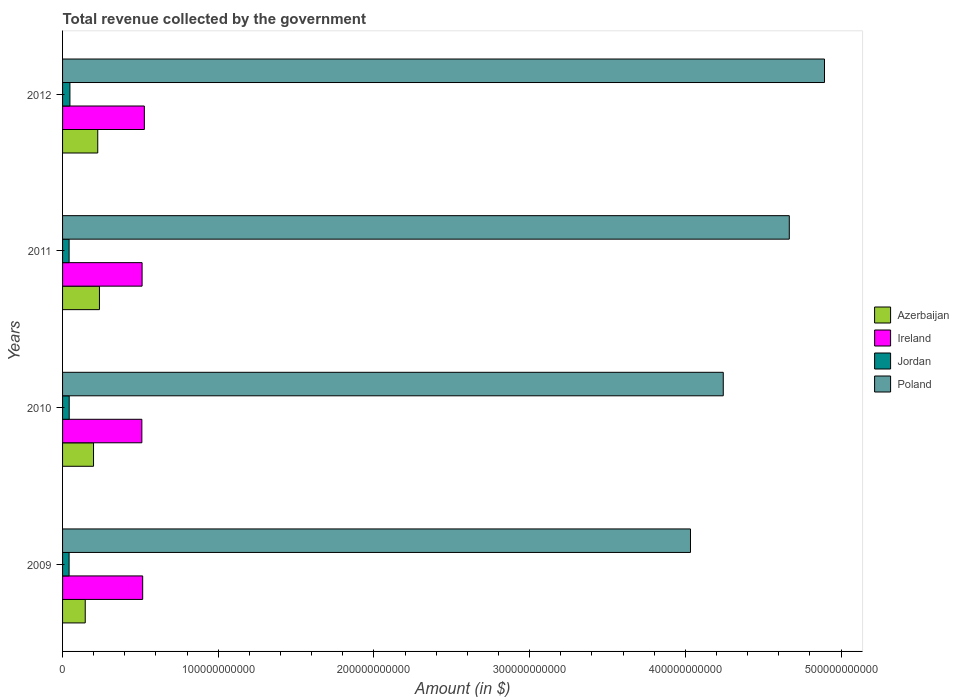How many different coloured bars are there?
Your answer should be compact. 4. How many groups of bars are there?
Give a very brief answer. 4. Are the number of bars per tick equal to the number of legend labels?
Offer a terse response. Yes. How many bars are there on the 3rd tick from the top?
Keep it short and to the point. 4. What is the label of the 1st group of bars from the top?
Offer a very short reply. 2012. What is the total revenue collected by the government in Azerbaijan in 2011?
Make the answer very short. 2.37e+1. Across all years, what is the maximum total revenue collected by the government in Azerbaijan?
Ensure brevity in your answer.  2.37e+1. Across all years, what is the minimum total revenue collected by the government in Poland?
Offer a very short reply. 4.03e+11. In which year was the total revenue collected by the government in Azerbaijan maximum?
Ensure brevity in your answer.  2011. What is the total total revenue collected by the government in Ireland in the graph?
Make the answer very short. 2.06e+11. What is the difference between the total revenue collected by the government in Ireland in 2009 and that in 2011?
Your response must be concise. 3.85e+08. What is the difference between the total revenue collected by the government in Ireland in 2009 and the total revenue collected by the government in Poland in 2012?
Ensure brevity in your answer.  -4.38e+11. What is the average total revenue collected by the government in Jordan per year?
Offer a very short reply. 4.34e+09. In the year 2011, what is the difference between the total revenue collected by the government in Jordan and total revenue collected by the government in Azerbaijan?
Offer a very short reply. -1.95e+1. In how many years, is the total revenue collected by the government in Jordan greater than 460000000000 $?
Ensure brevity in your answer.  0. What is the ratio of the total revenue collected by the government in Ireland in 2009 to that in 2011?
Provide a short and direct response. 1.01. What is the difference between the highest and the second highest total revenue collected by the government in Azerbaijan?
Provide a short and direct response. 1.09e+09. What is the difference between the highest and the lowest total revenue collected by the government in Azerbaijan?
Make the answer very short. 9.13e+09. Is the sum of the total revenue collected by the government in Azerbaijan in 2010 and 2011 greater than the maximum total revenue collected by the government in Jordan across all years?
Ensure brevity in your answer.  Yes. What does the 3rd bar from the top in 2012 represents?
Provide a short and direct response. Ireland. What does the 2nd bar from the bottom in 2010 represents?
Your answer should be compact. Ireland. Are all the bars in the graph horizontal?
Offer a very short reply. Yes. How many years are there in the graph?
Ensure brevity in your answer.  4. What is the difference between two consecutive major ticks on the X-axis?
Ensure brevity in your answer.  1.00e+11. Does the graph contain any zero values?
Give a very brief answer. No. Where does the legend appear in the graph?
Offer a terse response. Center right. What is the title of the graph?
Your answer should be compact. Total revenue collected by the government. What is the label or title of the X-axis?
Make the answer very short. Amount (in $). What is the Amount (in $) in Azerbaijan in 2009?
Offer a very short reply. 1.46e+1. What is the Amount (in $) in Ireland in 2009?
Your answer should be very brief. 5.15e+1. What is the Amount (in $) of Jordan in 2009?
Your answer should be very brief. 4.19e+09. What is the Amount (in $) in Poland in 2009?
Offer a very short reply. 4.03e+11. What is the Amount (in $) of Azerbaijan in 2010?
Offer a very short reply. 1.99e+1. What is the Amount (in $) of Ireland in 2010?
Keep it short and to the point. 5.09e+1. What is the Amount (in $) of Jordan in 2010?
Your answer should be compact. 4.26e+09. What is the Amount (in $) in Poland in 2010?
Your response must be concise. 4.24e+11. What is the Amount (in $) in Azerbaijan in 2011?
Keep it short and to the point. 2.37e+1. What is the Amount (in $) in Ireland in 2011?
Your response must be concise. 5.11e+1. What is the Amount (in $) of Jordan in 2011?
Your response must be concise. 4.20e+09. What is the Amount (in $) of Poland in 2011?
Make the answer very short. 4.67e+11. What is the Amount (in $) in Azerbaijan in 2012?
Your answer should be very brief. 2.26e+1. What is the Amount (in $) of Ireland in 2012?
Make the answer very short. 5.25e+1. What is the Amount (in $) of Jordan in 2012?
Offer a very short reply. 4.73e+09. What is the Amount (in $) of Poland in 2012?
Ensure brevity in your answer.  4.89e+11. Across all years, what is the maximum Amount (in $) in Azerbaijan?
Give a very brief answer. 2.37e+1. Across all years, what is the maximum Amount (in $) of Ireland?
Make the answer very short. 5.25e+1. Across all years, what is the maximum Amount (in $) in Jordan?
Provide a short and direct response. 4.73e+09. Across all years, what is the maximum Amount (in $) in Poland?
Ensure brevity in your answer.  4.89e+11. Across all years, what is the minimum Amount (in $) in Azerbaijan?
Ensure brevity in your answer.  1.46e+1. Across all years, what is the minimum Amount (in $) of Ireland?
Provide a succinct answer. 5.09e+1. Across all years, what is the minimum Amount (in $) in Jordan?
Your answer should be very brief. 4.19e+09. Across all years, what is the minimum Amount (in $) in Poland?
Give a very brief answer. 4.03e+11. What is the total Amount (in $) of Azerbaijan in the graph?
Your answer should be compact. 8.07e+1. What is the total Amount (in $) in Ireland in the graph?
Give a very brief answer. 2.06e+11. What is the total Amount (in $) of Jordan in the graph?
Make the answer very short. 1.74e+1. What is the total Amount (in $) in Poland in the graph?
Your response must be concise. 1.78e+12. What is the difference between the Amount (in $) in Azerbaijan in 2009 and that in 2010?
Your answer should be very brief. -5.33e+09. What is the difference between the Amount (in $) in Ireland in 2009 and that in 2010?
Offer a very short reply. 5.34e+08. What is the difference between the Amount (in $) of Jordan in 2009 and that in 2010?
Ensure brevity in your answer.  -7.31e+07. What is the difference between the Amount (in $) of Poland in 2009 and that in 2010?
Provide a succinct answer. -2.11e+1. What is the difference between the Amount (in $) in Azerbaijan in 2009 and that in 2011?
Make the answer very short. -9.13e+09. What is the difference between the Amount (in $) in Ireland in 2009 and that in 2011?
Your answer should be very brief. 3.85e+08. What is the difference between the Amount (in $) of Jordan in 2009 and that in 2011?
Offer a very short reply. -1.11e+07. What is the difference between the Amount (in $) of Poland in 2009 and that in 2011?
Provide a short and direct response. -6.35e+1. What is the difference between the Amount (in $) in Azerbaijan in 2009 and that in 2012?
Give a very brief answer. -8.04e+09. What is the difference between the Amount (in $) of Ireland in 2009 and that in 2012?
Offer a very short reply. -1.07e+09. What is the difference between the Amount (in $) of Jordan in 2009 and that in 2012?
Keep it short and to the point. -5.39e+08. What is the difference between the Amount (in $) of Poland in 2009 and that in 2012?
Provide a succinct answer. -8.61e+1. What is the difference between the Amount (in $) of Azerbaijan in 2010 and that in 2011?
Your answer should be very brief. -3.80e+09. What is the difference between the Amount (in $) of Ireland in 2010 and that in 2011?
Your answer should be very brief. -1.49e+08. What is the difference between the Amount (in $) in Jordan in 2010 and that in 2011?
Ensure brevity in your answer.  6.20e+07. What is the difference between the Amount (in $) in Poland in 2010 and that in 2011?
Ensure brevity in your answer.  -4.24e+1. What is the difference between the Amount (in $) in Azerbaijan in 2010 and that in 2012?
Provide a succinct answer. -2.71e+09. What is the difference between the Amount (in $) of Ireland in 2010 and that in 2012?
Give a very brief answer. -1.60e+09. What is the difference between the Amount (in $) of Jordan in 2010 and that in 2012?
Your answer should be very brief. -4.66e+08. What is the difference between the Amount (in $) in Poland in 2010 and that in 2012?
Give a very brief answer. -6.50e+1. What is the difference between the Amount (in $) of Azerbaijan in 2011 and that in 2012?
Provide a short and direct response. 1.09e+09. What is the difference between the Amount (in $) in Ireland in 2011 and that in 2012?
Your response must be concise. -1.45e+09. What is the difference between the Amount (in $) in Jordan in 2011 and that in 2012?
Keep it short and to the point. -5.28e+08. What is the difference between the Amount (in $) of Poland in 2011 and that in 2012?
Offer a very short reply. -2.26e+1. What is the difference between the Amount (in $) of Azerbaijan in 2009 and the Amount (in $) of Ireland in 2010?
Your response must be concise. -3.64e+1. What is the difference between the Amount (in $) in Azerbaijan in 2009 and the Amount (in $) in Jordan in 2010?
Provide a succinct answer. 1.03e+1. What is the difference between the Amount (in $) in Azerbaijan in 2009 and the Amount (in $) in Poland in 2010?
Provide a short and direct response. -4.10e+11. What is the difference between the Amount (in $) in Ireland in 2009 and the Amount (in $) in Jordan in 2010?
Ensure brevity in your answer.  4.72e+1. What is the difference between the Amount (in $) of Ireland in 2009 and the Amount (in $) of Poland in 2010?
Provide a succinct answer. -3.73e+11. What is the difference between the Amount (in $) in Jordan in 2009 and the Amount (in $) in Poland in 2010?
Your response must be concise. -4.20e+11. What is the difference between the Amount (in $) of Azerbaijan in 2009 and the Amount (in $) of Ireland in 2011?
Provide a succinct answer. -3.65e+1. What is the difference between the Amount (in $) in Azerbaijan in 2009 and the Amount (in $) in Jordan in 2011?
Provide a succinct answer. 1.04e+1. What is the difference between the Amount (in $) in Azerbaijan in 2009 and the Amount (in $) in Poland in 2011?
Give a very brief answer. -4.52e+11. What is the difference between the Amount (in $) of Ireland in 2009 and the Amount (in $) of Jordan in 2011?
Your response must be concise. 4.73e+1. What is the difference between the Amount (in $) of Ireland in 2009 and the Amount (in $) of Poland in 2011?
Keep it short and to the point. -4.15e+11. What is the difference between the Amount (in $) in Jordan in 2009 and the Amount (in $) in Poland in 2011?
Make the answer very short. -4.63e+11. What is the difference between the Amount (in $) in Azerbaijan in 2009 and the Amount (in $) in Ireland in 2012?
Ensure brevity in your answer.  -3.80e+1. What is the difference between the Amount (in $) in Azerbaijan in 2009 and the Amount (in $) in Jordan in 2012?
Your answer should be compact. 9.83e+09. What is the difference between the Amount (in $) in Azerbaijan in 2009 and the Amount (in $) in Poland in 2012?
Make the answer very short. -4.75e+11. What is the difference between the Amount (in $) of Ireland in 2009 and the Amount (in $) of Jordan in 2012?
Provide a short and direct response. 4.67e+1. What is the difference between the Amount (in $) in Ireland in 2009 and the Amount (in $) in Poland in 2012?
Offer a very short reply. -4.38e+11. What is the difference between the Amount (in $) of Jordan in 2009 and the Amount (in $) of Poland in 2012?
Your response must be concise. -4.85e+11. What is the difference between the Amount (in $) of Azerbaijan in 2010 and the Amount (in $) of Ireland in 2011?
Offer a very short reply. -3.12e+1. What is the difference between the Amount (in $) in Azerbaijan in 2010 and the Amount (in $) in Jordan in 2011?
Give a very brief answer. 1.57e+1. What is the difference between the Amount (in $) of Azerbaijan in 2010 and the Amount (in $) of Poland in 2011?
Provide a succinct answer. -4.47e+11. What is the difference between the Amount (in $) of Ireland in 2010 and the Amount (in $) of Jordan in 2011?
Ensure brevity in your answer.  4.67e+1. What is the difference between the Amount (in $) in Ireland in 2010 and the Amount (in $) in Poland in 2011?
Provide a short and direct response. -4.16e+11. What is the difference between the Amount (in $) of Jordan in 2010 and the Amount (in $) of Poland in 2011?
Offer a terse response. -4.62e+11. What is the difference between the Amount (in $) in Azerbaijan in 2010 and the Amount (in $) in Ireland in 2012?
Keep it short and to the point. -3.26e+1. What is the difference between the Amount (in $) of Azerbaijan in 2010 and the Amount (in $) of Jordan in 2012?
Keep it short and to the point. 1.52e+1. What is the difference between the Amount (in $) of Azerbaijan in 2010 and the Amount (in $) of Poland in 2012?
Provide a short and direct response. -4.69e+11. What is the difference between the Amount (in $) in Ireland in 2010 and the Amount (in $) in Jordan in 2012?
Make the answer very short. 4.62e+1. What is the difference between the Amount (in $) of Ireland in 2010 and the Amount (in $) of Poland in 2012?
Your answer should be compact. -4.38e+11. What is the difference between the Amount (in $) of Jordan in 2010 and the Amount (in $) of Poland in 2012?
Make the answer very short. -4.85e+11. What is the difference between the Amount (in $) of Azerbaijan in 2011 and the Amount (in $) of Ireland in 2012?
Provide a succinct answer. -2.88e+1. What is the difference between the Amount (in $) of Azerbaijan in 2011 and the Amount (in $) of Jordan in 2012?
Offer a very short reply. 1.90e+1. What is the difference between the Amount (in $) of Azerbaijan in 2011 and the Amount (in $) of Poland in 2012?
Your answer should be very brief. -4.66e+11. What is the difference between the Amount (in $) in Ireland in 2011 and the Amount (in $) in Jordan in 2012?
Offer a terse response. 4.63e+1. What is the difference between the Amount (in $) in Ireland in 2011 and the Amount (in $) in Poland in 2012?
Provide a short and direct response. -4.38e+11. What is the difference between the Amount (in $) of Jordan in 2011 and the Amount (in $) of Poland in 2012?
Give a very brief answer. -4.85e+11. What is the average Amount (in $) in Azerbaijan per year?
Your answer should be compact. 2.02e+1. What is the average Amount (in $) of Ireland per year?
Keep it short and to the point. 5.15e+1. What is the average Amount (in $) in Jordan per year?
Offer a terse response. 4.34e+09. What is the average Amount (in $) in Poland per year?
Provide a succinct answer. 4.46e+11. In the year 2009, what is the difference between the Amount (in $) in Azerbaijan and Amount (in $) in Ireland?
Make the answer very short. -3.69e+1. In the year 2009, what is the difference between the Amount (in $) in Azerbaijan and Amount (in $) in Jordan?
Your answer should be compact. 1.04e+1. In the year 2009, what is the difference between the Amount (in $) of Azerbaijan and Amount (in $) of Poland?
Ensure brevity in your answer.  -3.89e+11. In the year 2009, what is the difference between the Amount (in $) of Ireland and Amount (in $) of Jordan?
Offer a terse response. 4.73e+1. In the year 2009, what is the difference between the Amount (in $) of Ireland and Amount (in $) of Poland?
Provide a succinct answer. -3.52e+11. In the year 2009, what is the difference between the Amount (in $) of Jordan and Amount (in $) of Poland?
Keep it short and to the point. -3.99e+11. In the year 2010, what is the difference between the Amount (in $) of Azerbaijan and Amount (in $) of Ireland?
Your answer should be compact. -3.10e+1. In the year 2010, what is the difference between the Amount (in $) in Azerbaijan and Amount (in $) in Jordan?
Your answer should be compact. 1.56e+1. In the year 2010, what is the difference between the Amount (in $) in Azerbaijan and Amount (in $) in Poland?
Provide a succinct answer. -4.04e+11. In the year 2010, what is the difference between the Amount (in $) of Ireland and Amount (in $) of Jordan?
Keep it short and to the point. 4.67e+1. In the year 2010, what is the difference between the Amount (in $) in Ireland and Amount (in $) in Poland?
Offer a very short reply. -3.73e+11. In the year 2010, what is the difference between the Amount (in $) of Jordan and Amount (in $) of Poland?
Offer a terse response. -4.20e+11. In the year 2011, what is the difference between the Amount (in $) of Azerbaijan and Amount (in $) of Ireland?
Give a very brief answer. -2.74e+1. In the year 2011, what is the difference between the Amount (in $) of Azerbaijan and Amount (in $) of Jordan?
Your answer should be compact. 1.95e+1. In the year 2011, what is the difference between the Amount (in $) in Azerbaijan and Amount (in $) in Poland?
Your answer should be compact. -4.43e+11. In the year 2011, what is the difference between the Amount (in $) of Ireland and Amount (in $) of Jordan?
Provide a short and direct response. 4.69e+1. In the year 2011, what is the difference between the Amount (in $) of Ireland and Amount (in $) of Poland?
Provide a succinct answer. -4.16e+11. In the year 2011, what is the difference between the Amount (in $) in Jordan and Amount (in $) in Poland?
Offer a terse response. -4.63e+11. In the year 2012, what is the difference between the Amount (in $) of Azerbaijan and Amount (in $) of Ireland?
Provide a short and direct response. -2.99e+1. In the year 2012, what is the difference between the Amount (in $) of Azerbaijan and Amount (in $) of Jordan?
Provide a succinct answer. 1.79e+1. In the year 2012, what is the difference between the Amount (in $) of Azerbaijan and Amount (in $) of Poland?
Provide a short and direct response. -4.67e+11. In the year 2012, what is the difference between the Amount (in $) in Ireland and Amount (in $) in Jordan?
Your response must be concise. 4.78e+1. In the year 2012, what is the difference between the Amount (in $) of Ireland and Amount (in $) of Poland?
Your answer should be very brief. -4.37e+11. In the year 2012, what is the difference between the Amount (in $) of Jordan and Amount (in $) of Poland?
Your answer should be very brief. -4.85e+11. What is the ratio of the Amount (in $) of Azerbaijan in 2009 to that in 2010?
Your response must be concise. 0.73. What is the ratio of the Amount (in $) of Ireland in 2009 to that in 2010?
Your answer should be very brief. 1.01. What is the ratio of the Amount (in $) in Jordan in 2009 to that in 2010?
Keep it short and to the point. 0.98. What is the ratio of the Amount (in $) of Poland in 2009 to that in 2010?
Give a very brief answer. 0.95. What is the ratio of the Amount (in $) in Azerbaijan in 2009 to that in 2011?
Keep it short and to the point. 0.61. What is the ratio of the Amount (in $) of Ireland in 2009 to that in 2011?
Offer a very short reply. 1.01. What is the ratio of the Amount (in $) in Jordan in 2009 to that in 2011?
Provide a short and direct response. 1. What is the ratio of the Amount (in $) in Poland in 2009 to that in 2011?
Ensure brevity in your answer.  0.86. What is the ratio of the Amount (in $) in Azerbaijan in 2009 to that in 2012?
Make the answer very short. 0.64. What is the ratio of the Amount (in $) of Ireland in 2009 to that in 2012?
Offer a terse response. 0.98. What is the ratio of the Amount (in $) in Jordan in 2009 to that in 2012?
Offer a very short reply. 0.89. What is the ratio of the Amount (in $) in Poland in 2009 to that in 2012?
Keep it short and to the point. 0.82. What is the ratio of the Amount (in $) in Azerbaijan in 2010 to that in 2011?
Provide a short and direct response. 0.84. What is the ratio of the Amount (in $) in Jordan in 2010 to that in 2011?
Make the answer very short. 1.01. What is the ratio of the Amount (in $) in Poland in 2010 to that in 2011?
Offer a terse response. 0.91. What is the ratio of the Amount (in $) in Azerbaijan in 2010 to that in 2012?
Offer a very short reply. 0.88. What is the ratio of the Amount (in $) in Ireland in 2010 to that in 2012?
Offer a very short reply. 0.97. What is the ratio of the Amount (in $) of Jordan in 2010 to that in 2012?
Your answer should be very brief. 0.9. What is the ratio of the Amount (in $) of Poland in 2010 to that in 2012?
Your response must be concise. 0.87. What is the ratio of the Amount (in $) in Azerbaijan in 2011 to that in 2012?
Provide a short and direct response. 1.05. What is the ratio of the Amount (in $) in Ireland in 2011 to that in 2012?
Provide a short and direct response. 0.97. What is the ratio of the Amount (in $) in Jordan in 2011 to that in 2012?
Provide a short and direct response. 0.89. What is the ratio of the Amount (in $) in Poland in 2011 to that in 2012?
Ensure brevity in your answer.  0.95. What is the difference between the highest and the second highest Amount (in $) of Azerbaijan?
Ensure brevity in your answer.  1.09e+09. What is the difference between the highest and the second highest Amount (in $) of Ireland?
Your answer should be very brief. 1.07e+09. What is the difference between the highest and the second highest Amount (in $) in Jordan?
Provide a short and direct response. 4.66e+08. What is the difference between the highest and the second highest Amount (in $) of Poland?
Your answer should be very brief. 2.26e+1. What is the difference between the highest and the lowest Amount (in $) of Azerbaijan?
Provide a succinct answer. 9.13e+09. What is the difference between the highest and the lowest Amount (in $) of Ireland?
Provide a short and direct response. 1.60e+09. What is the difference between the highest and the lowest Amount (in $) in Jordan?
Offer a terse response. 5.39e+08. What is the difference between the highest and the lowest Amount (in $) of Poland?
Give a very brief answer. 8.61e+1. 